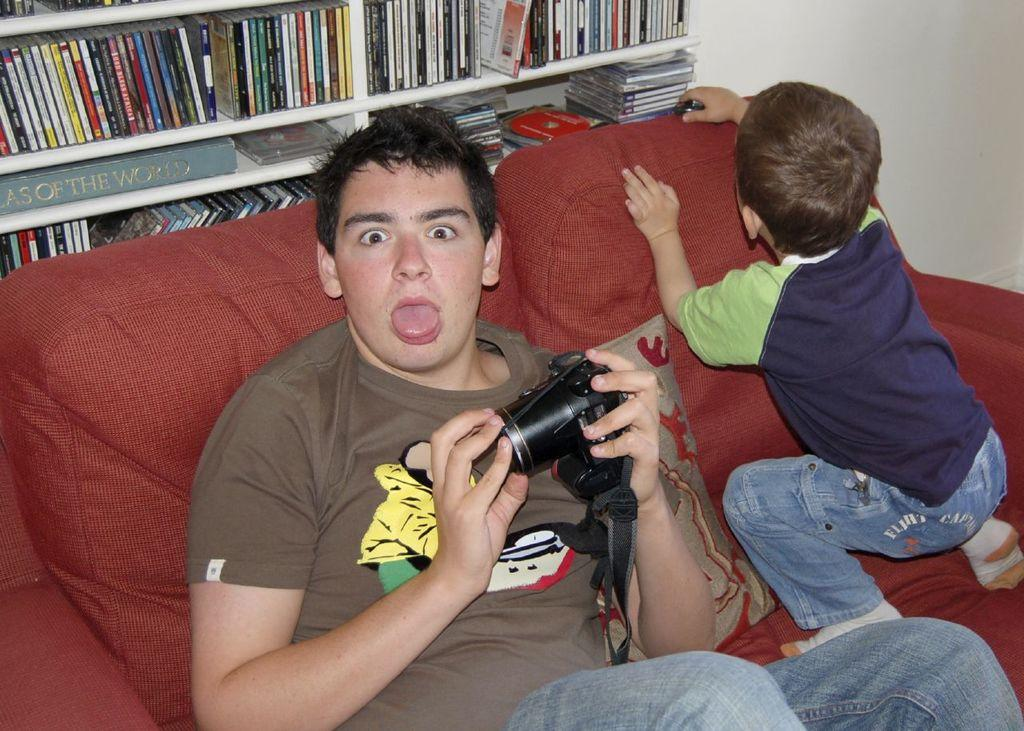How many boys are in the image? There are two boys in the image. What are the boys doing in the image? Both boys are sitting on a sofa. What is one of the boys holding? One boy is holding a camera. Can you describe the surroundings in the image? There are many books present. What type of apple is being eaten by the boy in the image? There is no apple present in the image; the boy is holding a camera. 